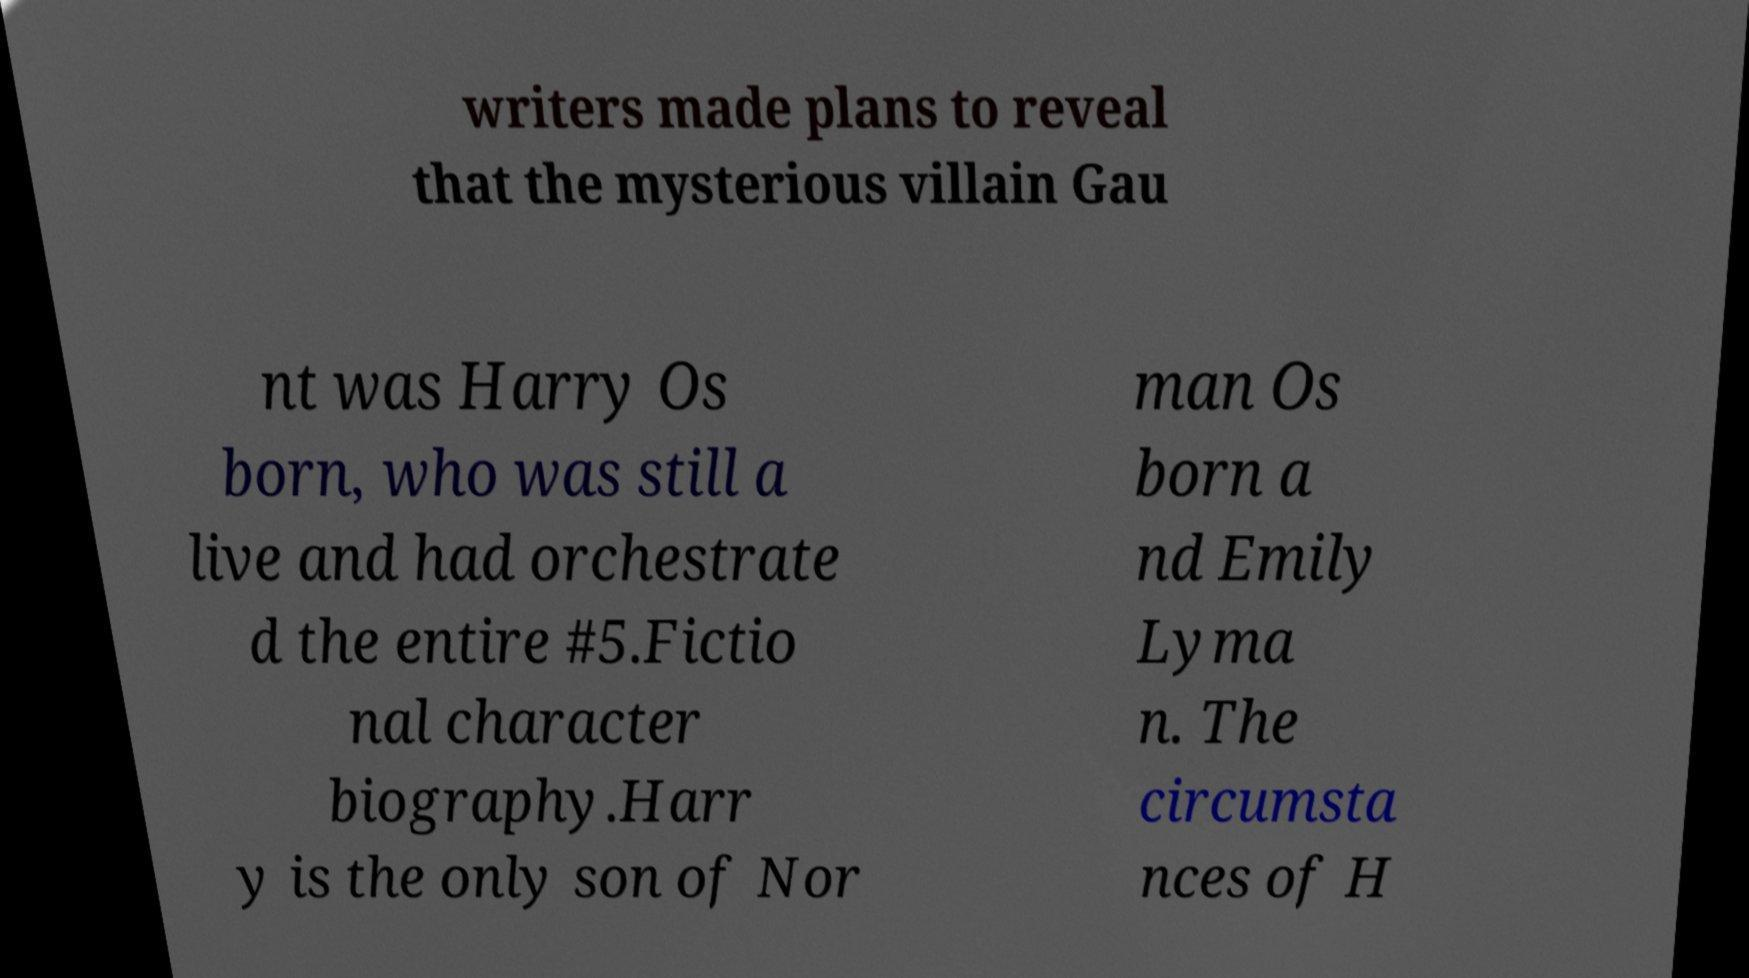Could you assist in decoding the text presented in this image and type it out clearly? writers made plans to reveal that the mysterious villain Gau nt was Harry Os born, who was still a live and had orchestrate d the entire #5.Fictio nal character biography.Harr y is the only son of Nor man Os born a nd Emily Lyma n. The circumsta nces of H 